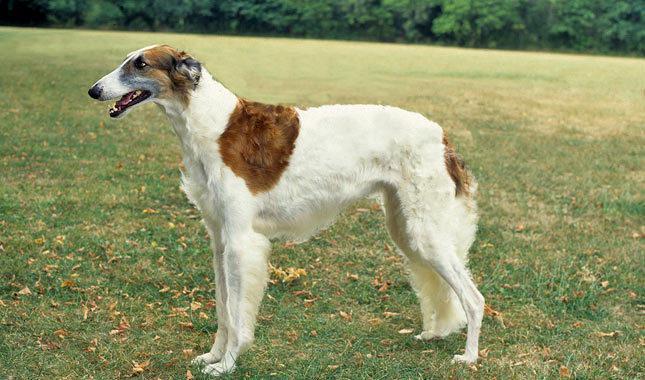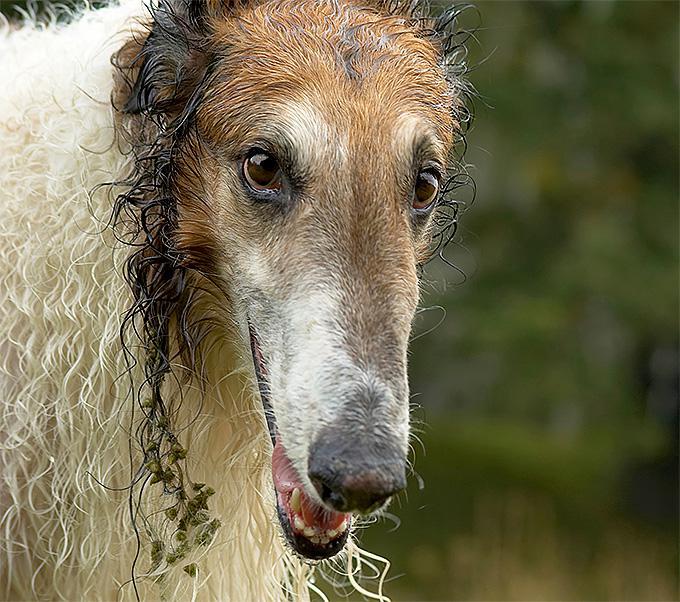The first image is the image on the left, the second image is the image on the right. Evaluate the accuracy of this statement regarding the images: "There are at least two dogs in the image on the left.". Is it true? Answer yes or no. No. The first image is the image on the left, the second image is the image on the right. Evaluate the accuracy of this statement regarding the images: "There is exactly one dog in each image.". Is it true? Answer yes or no. Yes. 